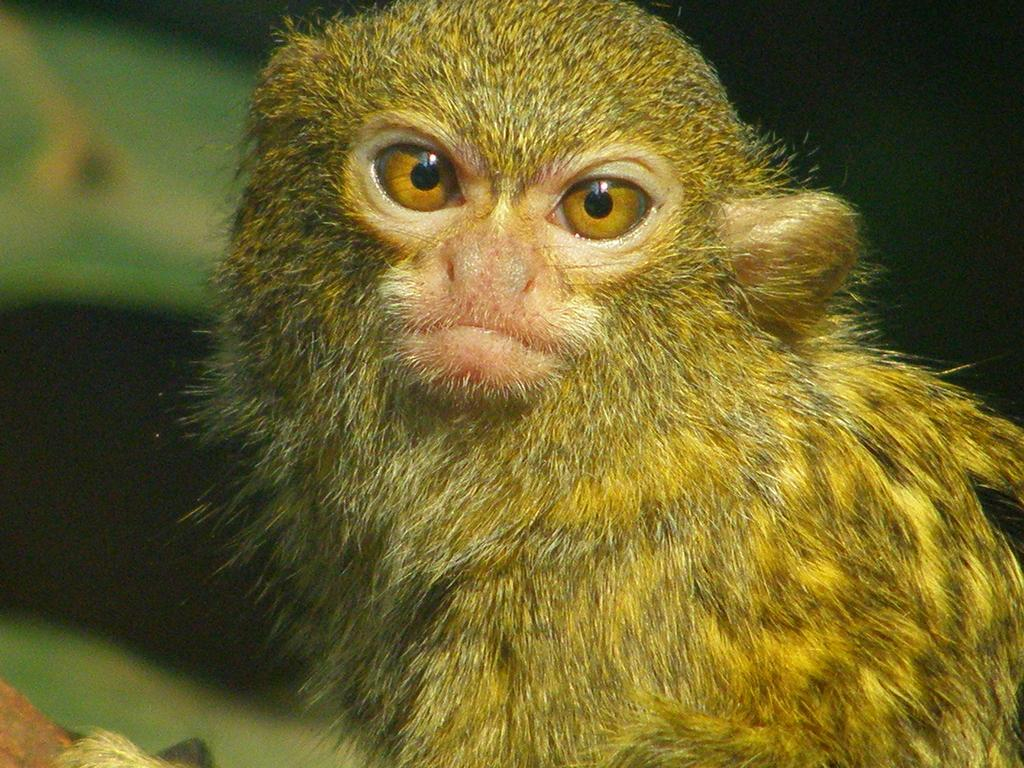What is the main subject in the foreground of the image? There is a monkey in the foreground of the image. Can you describe the background of the image? The background of the image is blurry. What type of eggnog is the monkey holding in the image? There is no eggnog present in the image; it features a monkey in the foreground. What type of can is visible in the grass in the image? There is no can or grass present in the image; it only features a monkey in the foreground and a blurry background. 